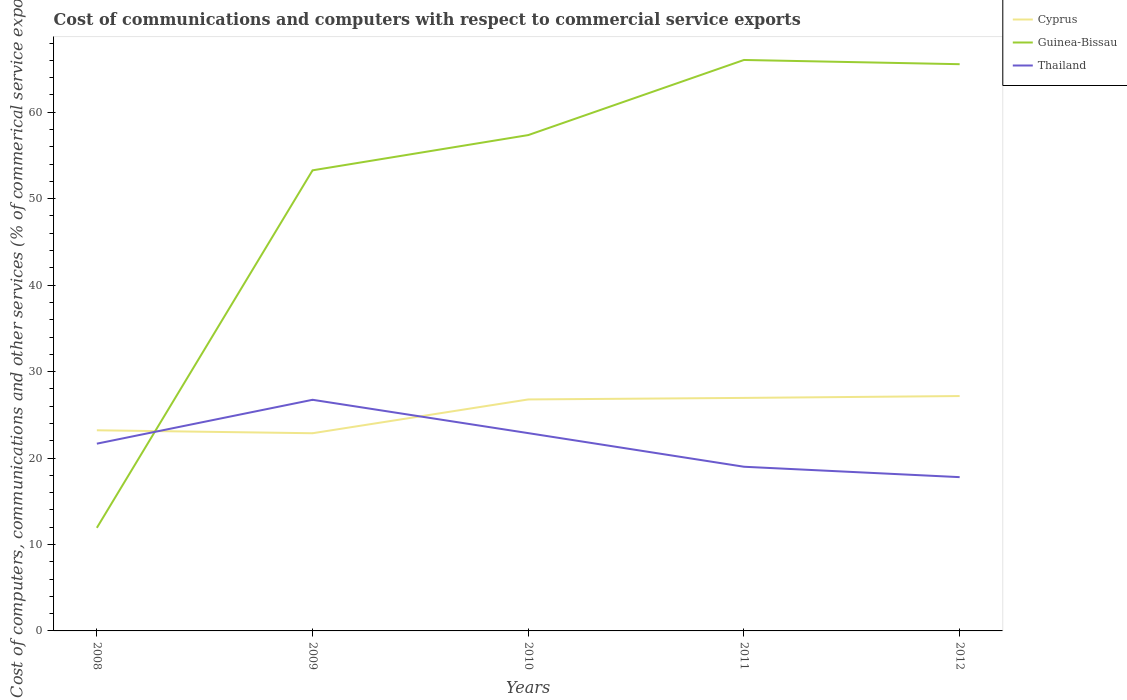Does the line corresponding to Guinea-Bissau intersect with the line corresponding to Cyprus?
Your response must be concise. Yes. Is the number of lines equal to the number of legend labels?
Offer a terse response. Yes. Across all years, what is the maximum cost of communications and computers in Guinea-Bissau?
Provide a short and direct response. 11.93. What is the total cost of communications and computers in Thailand in the graph?
Your response must be concise. 7.75. What is the difference between the highest and the second highest cost of communications and computers in Guinea-Bissau?
Keep it short and to the point. 54.12. How many years are there in the graph?
Make the answer very short. 5. Does the graph contain any zero values?
Offer a very short reply. No. Where does the legend appear in the graph?
Keep it short and to the point. Top right. How many legend labels are there?
Your answer should be compact. 3. How are the legend labels stacked?
Provide a short and direct response. Vertical. What is the title of the graph?
Make the answer very short. Cost of communications and computers with respect to commercial service exports. Does "Barbados" appear as one of the legend labels in the graph?
Provide a succinct answer. No. What is the label or title of the Y-axis?
Give a very brief answer. Cost of computers, communications and other services (% of commerical service exports). What is the Cost of computers, communications and other services (% of commerical service exports) of Cyprus in 2008?
Give a very brief answer. 23.21. What is the Cost of computers, communications and other services (% of commerical service exports) of Guinea-Bissau in 2008?
Your answer should be compact. 11.93. What is the Cost of computers, communications and other services (% of commerical service exports) in Thailand in 2008?
Make the answer very short. 21.66. What is the Cost of computers, communications and other services (% of commerical service exports) of Cyprus in 2009?
Your answer should be compact. 22.87. What is the Cost of computers, communications and other services (% of commerical service exports) in Guinea-Bissau in 2009?
Your answer should be compact. 53.28. What is the Cost of computers, communications and other services (% of commerical service exports) of Thailand in 2009?
Ensure brevity in your answer.  26.74. What is the Cost of computers, communications and other services (% of commerical service exports) of Cyprus in 2010?
Give a very brief answer. 26.78. What is the Cost of computers, communications and other services (% of commerical service exports) in Guinea-Bissau in 2010?
Your answer should be compact. 57.36. What is the Cost of computers, communications and other services (% of commerical service exports) of Thailand in 2010?
Keep it short and to the point. 22.88. What is the Cost of computers, communications and other services (% of commerical service exports) in Cyprus in 2011?
Keep it short and to the point. 26.95. What is the Cost of computers, communications and other services (% of commerical service exports) in Guinea-Bissau in 2011?
Provide a short and direct response. 66.05. What is the Cost of computers, communications and other services (% of commerical service exports) in Thailand in 2011?
Provide a short and direct response. 18.99. What is the Cost of computers, communications and other services (% of commerical service exports) of Cyprus in 2012?
Give a very brief answer. 27.17. What is the Cost of computers, communications and other services (% of commerical service exports) in Guinea-Bissau in 2012?
Offer a very short reply. 65.56. What is the Cost of computers, communications and other services (% of commerical service exports) in Thailand in 2012?
Make the answer very short. 17.79. Across all years, what is the maximum Cost of computers, communications and other services (% of commerical service exports) in Cyprus?
Provide a short and direct response. 27.17. Across all years, what is the maximum Cost of computers, communications and other services (% of commerical service exports) in Guinea-Bissau?
Your answer should be compact. 66.05. Across all years, what is the maximum Cost of computers, communications and other services (% of commerical service exports) in Thailand?
Make the answer very short. 26.74. Across all years, what is the minimum Cost of computers, communications and other services (% of commerical service exports) of Cyprus?
Provide a short and direct response. 22.87. Across all years, what is the minimum Cost of computers, communications and other services (% of commerical service exports) in Guinea-Bissau?
Offer a very short reply. 11.93. Across all years, what is the minimum Cost of computers, communications and other services (% of commerical service exports) in Thailand?
Your response must be concise. 17.79. What is the total Cost of computers, communications and other services (% of commerical service exports) of Cyprus in the graph?
Ensure brevity in your answer.  126.98. What is the total Cost of computers, communications and other services (% of commerical service exports) of Guinea-Bissau in the graph?
Keep it short and to the point. 254.17. What is the total Cost of computers, communications and other services (% of commerical service exports) in Thailand in the graph?
Your response must be concise. 108.06. What is the difference between the Cost of computers, communications and other services (% of commerical service exports) of Cyprus in 2008 and that in 2009?
Keep it short and to the point. 0.34. What is the difference between the Cost of computers, communications and other services (% of commerical service exports) of Guinea-Bissau in 2008 and that in 2009?
Your response must be concise. -41.35. What is the difference between the Cost of computers, communications and other services (% of commerical service exports) of Thailand in 2008 and that in 2009?
Provide a short and direct response. -5.08. What is the difference between the Cost of computers, communications and other services (% of commerical service exports) of Cyprus in 2008 and that in 2010?
Your answer should be compact. -3.57. What is the difference between the Cost of computers, communications and other services (% of commerical service exports) of Guinea-Bissau in 2008 and that in 2010?
Provide a succinct answer. -45.43. What is the difference between the Cost of computers, communications and other services (% of commerical service exports) in Thailand in 2008 and that in 2010?
Keep it short and to the point. -1.22. What is the difference between the Cost of computers, communications and other services (% of commerical service exports) of Cyprus in 2008 and that in 2011?
Provide a short and direct response. -3.74. What is the difference between the Cost of computers, communications and other services (% of commerical service exports) of Guinea-Bissau in 2008 and that in 2011?
Keep it short and to the point. -54.12. What is the difference between the Cost of computers, communications and other services (% of commerical service exports) in Thailand in 2008 and that in 2011?
Provide a succinct answer. 2.67. What is the difference between the Cost of computers, communications and other services (% of commerical service exports) in Cyprus in 2008 and that in 2012?
Offer a terse response. -3.96. What is the difference between the Cost of computers, communications and other services (% of commerical service exports) in Guinea-Bissau in 2008 and that in 2012?
Ensure brevity in your answer.  -53.63. What is the difference between the Cost of computers, communications and other services (% of commerical service exports) of Thailand in 2008 and that in 2012?
Offer a terse response. 3.87. What is the difference between the Cost of computers, communications and other services (% of commerical service exports) of Cyprus in 2009 and that in 2010?
Offer a very short reply. -3.91. What is the difference between the Cost of computers, communications and other services (% of commerical service exports) in Guinea-Bissau in 2009 and that in 2010?
Keep it short and to the point. -4.08. What is the difference between the Cost of computers, communications and other services (% of commerical service exports) in Thailand in 2009 and that in 2010?
Your answer should be compact. 3.86. What is the difference between the Cost of computers, communications and other services (% of commerical service exports) in Cyprus in 2009 and that in 2011?
Provide a short and direct response. -4.09. What is the difference between the Cost of computers, communications and other services (% of commerical service exports) of Guinea-Bissau in 2009 and that in 2011?
Your answer should be very brief. -12.77. What is the difference between the Cost of computers, communications and other services (% of commerical service exports) of Thailand in 2009 and that in 2011?
Make the answer very short. 7.75. What is the difference between the Cost of computers, communications and other services (% of commerical service exports) of Cyprus in 2009 and that in 2012?
Keep it short and to the point. -4.3. What is the difference between the Cost of computers, communications and other services (% of commerical service exports) of Guinea-Bissau in 2009 and that in 2012?
Offer a terse response. -12.28. What is the difference between the Cost of computers, communications and other services (% of commerical service exports) in Thailand in 2009 and that in 2012?
Offer a terse response. 8.95. What is the difference between the Cost of computers, communications and other services (% of commerical service exports) of Cyprus in 2010 and that in 2011?
Provide a short and direct response. -0.18. What is the difference between the Cost of computers, communications and other services (% of commerical service exports) of Guinea-Bissau in 2010 and that in 2011?
Offer a very short reply. -8.69. What is the difference between the Cost of computers, communications and other services (% of commerical service exports) of Thailand in 2010 and that in 2011?
Keep it short and to the point. 3.89. What is the difference between the Cost of computers, communications and other services (% of commerical service exports) in Cyprus in 2010 and that in 2012?
Your answer should be very brief. -0.39. What is the difference between the Cost of computers, communications and other services (% of commerical service exports) of Guinea-Bissau in 2010 and that in 2012?
Offer a terse response. -8.2. What is the difference between the Cost of computers, communications and other services (% of commerical service exports) of Thailand in 2010 and that in 2012?
Your answer should be very brief. 5.09. What is the difference between the Cost of computers, communications and other services (% of commerical service exports) of Cyprus in 2011 and that in 2012?
Offer a very short reply. -0.22. What is the difference between the Cost of computers, communications and other services (% of commerical service exports) of Guinea-Bissau in 2011 and that in 2012?
Provide a short and direct response. 0.49. What is the difference between the Cost of computers, communications and other services (% of commerical service exports) of Thailand in 2011 and that in 2012?
Provide a succinct answer. 1.2. What is the difference between the Cost of computers, communications and other services (% of commerical service exports) of Cyprus in 2008 and the Cost of computers, communications and other services (% of commerical service exports) of Guinea-Bissau in 2009?
Offer a very short reply. -30.07. What is the difference between the Cost of computers, communications and other services (% of commerical service exports) of Cyprus in 2008 and the Cost of computers, communications and other services (% of commerical service exports) of Thailand in 2009?
Offer a very short reply. -3.53. What is the difference between the Cost of computers, communications and other services (% of commerical service exports) in Guinea-Bissau in 2008 and the Cost of computers, communications and other services (% of commerical service exports) in Thailand in 2009?
Your answer should be very brief. -14.81. What is the difference between the Cost of computers, communications and other services (% of commerical service exports) of Cyprus in 2008 and the Cost of computers, communications and other services (% of commerical service exports) of Guinea-Bissau in 2010?
Give a very brief answer. -34.15. What is the difference between the Cost of computers, communications and other services (% of commerical service exports) of Cyprus in 2008 and the Cost of computers, communications and other services (% of commerical service exports) of Thailand in 2010?
Your response must be concise. 0.33. What is the difference between the Cost of computers, communications and other services (% of commerical service exports) in Guinea-Bissau in 2008 and the Cost of computers, communications and other services (% of commerical service exports) in Thailand in 2010?
Offer a terse response. -10.96. What is the difference between the Cost of computers, communications and other services (% of commerical service exports) of Cyprus in 2008 and the Cost of computers, communications and other services (% of commerical service exports) of Guinea-Bissau in 2011?
Ensure brevity in your answer.  -42.84. What is the difference between the Cost of computers, communications and other services (% of commerical service exports) of Cyprus in 2008 and the Cost of computers, communications and other services (% of commerical service exports) of Thailand in 2011?
Provide a short and direct response. 4.22. What is the difference between the Cost of computers, communications and other services (% of commerical service exports) in Guinea-Bissau in 2008 and the Cost of computers, communications and other services (% of commerical service exports) in Thailand in 2011?
Keep it short and to the point. -7.07. What is the difference between the Cost of computers, communications and other services (% of commerical service exports) in Cyprus in 2008 and the Cost of computers, communications and other services (% of commerical service exports) in Guinea-Bissau in 2012?
Provide a short and direct response. -42.35. What is the difference between the Cost of computers, communications and other services (% of commerical service exports) in Cyprus in 2008 and the Cost of computers, communications and other services (% of commerical service exports) in Thailand in 2012?
Make the answer very short. 5.42. What is the difference between the Cost of computers, communications and other services (% of commerical service exports) in Guinea-Bissau in 2008 and the Cost of computers, communications and other services (% of commerical service exports) in Thailand in 2012?
Your response must be concise. -5.86. What is the difference between the Cost of computers, communications and other services (% of commerical service exports) in Cyprus in 2009 and the Cost of computers, communications and other services (% of commerical service exports) in Guinea-Bissau in 2010?
Keep it short and to the point. -34.49. What is the difference between the Cost of computers, communications and other services (% of commerical service exports) of Cyprus in 2009 and the Cost of computers, communications and other services (% of commerical service exports) of Thailand in 2010?
Provide a succinct answer. -0.01. What is the difference between the Cost of computers, communications and other services (% of commerical service exports) of Guinea-Bissau in 2009 and the Cost of computers, communications and other services (% of commerical service exports) of Thailand in 2010?
Keep it short and to the point. 30.4. What is the difference between the Cost of computers, communications and other services (% of commerical service exports) in Cyprus in 2009 and the Cost of computers, communications and other services (% of commerical service exports) in Guinea-Bissau in 2011?
Offer a very short reply. -43.18. What is the difference between the Cost of computers, communications and other services (% of commerical service exports) of Cyprus in 2009 and the Cost of computers, communications and other services (% of commerical service exports) of Thailand in 2011?
Your response must be concise. 3.88. What is the difference between the Cost of computers, communications and other services (% of commerical service exports) of Guinea-Bissau in 2009 and the Cost of computers, communications and other services (% of commerical service exports) of Thailand in 2011?
Provide a short and direct response. 34.29. What is the difference between the Cost of computers, communications and other services (% of commerical service exports) of Cyprus in 2009 and the Cost of computers, communications and other services (% of commerical service exports) of Guinea-Bissau in 2012?
Keep it short and to the point. -42.69. What is the difference between the Cost of computers, communications and other services (% of commerical service exports) of Cyprus in 2009 and the Cost of computers, communications and other services (% of commerical service exports) of Thailand in 2012?
Offer a very short reply. 5.08. What is the difference between the Cost of computers, communications and other services (% of commerical service exports) of Guinea-Bissau in 2009 and the Cost of computers, communications and other services (% of commerical service exports) of Thailand in 2012?
Provide a short and direct response. 35.49. What is the difference between the Cost of computers, communications and other services (% of commerical service exports) in Cyprus in 2010 and the Cost of computers, communications and other services (% of commerical service exports) in Guinea-Bissau in 2011?
Ensure brevity in your answer.  -39.27. What is the difference between the Cost of computers, communications and other services (% of commerical service exports) in Cyprus in 2010 and the Cost of computers, communications and other services (% of commerical service exports) in Thailand in 2011?
Ensure brevity in your answer.  7.79. What is the difference between the Cost of computers, communications and other services (% of commerical service exports) in Guinea-Bissau in 2010 and the Cost of computers, communications and other services (% of commerical service exports) in Thailand in 2011?
Offer a very short reply. 38.37. What is the difference between the Cost of computers, communications and other services (% of commerical service exports) of Cyprus in 2010 and the Cost of computers, communications and other services (% of commerical service exports) of Guinea-Bissau in 2012?
Offer a terse response. -38.78. What is the difference between the Cost of computers, communications and other services (% of commerical service exports) of Cyprus in 2010 and the Cost of computers, communications and other services (% of commerical service exports) of Thailand in 2012?
Your answer should be very brief. 8.99. What is the difference between the Cost of computers, communications and other services (% of commerical service exports) in Guinea-Bissau in 2010 and the Cost of computers, communications and other services (% of commerical service exports) in Thailand in 2012?
Offer a terse response. 39.57. What is the difference between the Cost of computers, communications and other services (% of commerical service exports) of Cyprus in 2011 and the Cost of computers, communications and other services (% of commerical service exports) of Guinea-Bissau in 2012?
Make the answer very short. -38.6. What is the difference between the Cost of computers, communications and other services (% of commerical service exports) in Cyprus in 2011 and the Cost of computers, communications and other services (% of commerical service exports) in Thailand in 2012?
Give a very brief answer. 9.16. What is the difference between the Cost of computers, communications and other services (% of commerical service exports) of Guinea-Bissau in 2011 and the Cost of computers, communications and other services (% of commerical service exports) of Thailand in 2012?
Provide a succinct answer. 48.26. What is the average Cost of computers, communications and other services (% of commerical service exports) in Cyprus per year?
Offer a very short reply. 25.4. What is the average Cost of computers, communications and other services (% of commerical service exports) in Guinea-Bissau per year?
Keep it short and to the point. 50.83. What is the average Cost of computers, communications and other services (% of commerical service exports) in Thailand per year?
Provide a short and direct response. 21.61. In the year 2008, what is the difference between the Cost of computers, communications and other services (% of commerical service exports) in Cyprus and Cost of computers, communications and other services (% of commerical service exports) in Guinea-Bissau?
Offer a very short reply. 11.28. In the year 2008, what is the difference between the Cost of computers, communications and other services (% of commerical service exports) of Cyprus and Cost of computers, communications and other services (% of commerical service exports) of Thailand?
Your answer should be very brief. 1.55. In the year 2008, what is the difference between the Cost of computers, communications and other services (% of commerical service exports) in Guinea-Bissau and Cost of computers, communications and other services (% of commerical service exports) in Thailand?
Provide a short and direct response. -9.74. In the year 2009, what is the difference between the Cost of computers, communications and other services (% of commerical service exports) in Cyprus and Cost of computers, communications and other services (% of commerical service exports) in Guinea-Bissau?
Provide a short and direct response. -30.41. In the year 2009, what is the difference between the Cost of computers, communications and other services (% of commerical service exports) of Cyprus and Cost of computers, communications and other services (% of commerical service exports) of Thailand?
Provide a short and direct response. -3.87. In the year 2009, what is the difference between the Cost of computers, communications and other services (% of commerical service exports) in Guinea-Bissau and Cost of computers, communications and other services (% of commerical service exports) in Thailand?
Your answer should be very brief. 26.54. In the year 2010, what is the difference between the Cost of computers, communications and other services (% of commerical service exports) in Cyprus and Cost of computers, communications and other services (% of commerical service exports) in Guinea-Bissau?
Make the answer very short. -30.58. In the year 2010, what is the difference between the Cost of computers, communications and other services (% of commerical service exports) in Cyprus and Cost of computers, communications and other services (% of commerical service exports) in Thailand?
Make the answer very short. 3.9. In the year 2010, what is the difference between the Cost of computers, communications and other services (% of commerical service exports) in Guinea-Bissau and Cost of computers, communications and other services (% of commerical service exports) in Thailand?
Your answer should be compact. 34.48. In the year 2011, what is the difference between the Cost of computers, communications and other services (% of commerical service exports) of Cyprus and Cost of computers, communications and other services (% of commerical service exports) of Guinea-Bissau?
Make the answer very short. -39.09. In the year 2011, what is the difference between the Cost of computers, communications and other services (% of commerical service exports) of Cyprus and Cost of computers, communications and other services (% of commerical service exports) of Thailand?
Offer a very short reply. 7.96. In the year 2011, what is the difference between the Cost of computers, communications and other services (% of commerical service exports) of Guinea-Bissau and Cost of computers, communications and other services (% of commerical service exports) of Thailand?
Make the answer very short. 47.06. In the year 2012, what is the difference between the Cost of computers, communications and other services (% of commerical service exports) of Cyprus and Cost of computers, communications and other services (% of commerical service exports) of Guinea-Bissau?
Provide a short and direct response. -38.39. In the year 2012, what is the difference between the Cost of computers, communications and other services (% of commerical service exports) of Cyprus and Cost of computers, communications and other services (% of commerical service exports) of Thailand?
Provide a short and direct response. 9.38. In the year 2012, what is the difference between the Cost of computers, communications and other services (% of commerical service exports) in Guinea-Bissau and Cost of computers, communications and other services (% of commerical service exports) in Thailand?
Ensure brevity in your answer.  47.77. What is the ratio of the Cost of computers, communications and other services (% of commerical service exports) in Cyprus in 2008 to that in 2009?
Make the answer very short. 1.01. What is the ratio of the Cost of computers, communications and other services (% of commerical service exports) in Guinea-Bissau in 2008 to that in 2009?
Provide a succinct answer. 0.22. What is the ratio of the Cost of computers, communications and other services (% of commerical service exports) of Thailand in 2008 to that in 2009?
Your response must be concise. 0.81. What is the ratio of the Cost of computers, communications and other services (% of commerical service exports) of Cyprus in 2008 to that in 2010?
Your answer should be very brief. 0.87. What is the ratio of the Cost of computers, communications and other services (% of commerical service exports) of Guinea-Bissau in 2008 to that in 2010?
Ensure brevity in your answer.  0.21. What is the ratio of the Cost of computers, communications and other services (% of commerical service exports) of Thailand in 2008 to that in 2010?
Give a very brief answer. 0.95. What is the ratio of the Cost of computers, communications and other services (% of commerical service exports) in Cyprus in 2008 to that in 2011?
Your answer should be compact. 0.86. What is the ratio of the Cost of computers, communications and other services (% of commerical service exports) of Guinea-Bissau in 2008 to that in 2011?
Offer a very short reply. 0.18. What is the ratio of the Cost of computers, communications and other services (% of commerical service exports) of Thailand in 2008 to that in 2011?
Your response must be concise. 1.14. What is the ratio of the Cost of computers, communications and other services (% of commerical service exports) of Cyprus in 2008 to that in 2012?
Make the answer very short. 0.85. What is the ratio of the Cost of computers, communications and other services (% of commerical service exports) in Guinea-Bissau in 2008 to that in 2012?
Provide a short and direct response. 0.18. What is the ratio of the Cost of computers, communications and other services (% of commerical service exports) of Thailand in 2008 to that in 2012?
Offer a very short reply. 1.22. What is the ratio of the Cost of computers, communications and other services (% of commerical service exports) of Cyprus in 2009 to that in 2010?
Keep it short and to the point. 0.85. What is the ratio of the Cost of computers, communications and other services (% of commerical service exports) in Guinea-Bissau in 2009 to that in 2010?
Your answer should be very brief. 0.93. What is the ratio of the Cost of computers, communications and other services (% of commerical service exports) in Thailand in 2009 to that in 2010?
Make the answer very short. 1.17. What is the ratio of the Cost of computers, communications and other services (% of commerical service exports) of Cyprus in 2009 to that in 2011?
Offer a very short reply. 0.85. What is the ratio of the Cost of computers, communications and other services (% of commerical service exports) of Guinea-Bissau in 2009 to that in 2011?
Keep it short and to the point. 0.81. What is the ratio of the Cost of computers, communications and other services (% of commerical service exports) of Thailand in 2009 to that in 2011?
Your answer should be very brief. 1.41. What is the ratio of the Cost of computers, communications and other services (% of commerical service exports) in Cyprus in 2009 to that in 2012?
Keep it short and to the point. 0.84. What is the ratio of the Cost of computers, communications and other services (% of commerical service exports) of Guinea-Bissau in 2009 to that in 2012?
Your answer should be compact. 0.81. What is the ratio of the Cost of computers, communications and other services (% of commerical service exports) of Thailand in 2009 to that in 2012?
Ensure brevity in your answer.  1.5. What is the ratio of the Cost of computers, communications and other services (% of commerical service exports) of Cyprus in 2010 to that in 2011?
Make the answer very short. 0.99. What is the ratio of the Cost of computers, communications and other services (% of commerical service exports) of Guinea-Bissau in 2010 to that in 2011?
Keep it short and to the point. 0.87. What is the ratio of the Cost of computers, communications and other services (% of commerical service exports) in Thailand in 2010 to that in 2011?
Provide a succinct answer. 1.2. What is the ratio of the Cost of computers, communications and other services (% of commerical service exports) in Cyprus in 2010 to that in 2012?
Provide a short and direct response. 0.99. What is the ratio of the Cost of computers, communications and other services (% of commerical service exports) of Guinea-Bissau in 2010 to that in 2012?
Make the answer very short. 0.87. What is the ratio of the Cost of computers, communications and other services (% of commerical service exports) in Thailand in 2010 to that in 2012?
Provide a succinct answer. 1.29. What is the ratio of the Cost of computers, communications and other services (% of commerical service exports) of Guinea-Bissau in 2011 to that in 2012?
Your answer should be compact. 1.01. What is the ratio of the Cost of computers, communications and other services (% of commerical service exports) in Thailand in 2011 to that in 2012?
Ensure brevity in your answer.  1.07. What is the difference between the highest and the second highest Cost of computers, communications and other services (% of commerical service exports) in Cyprus?
Give a very brief answer. 0.22. What is the difference between the highest and the second highest Cost of computers, communications and other services (% of commerical service exports) in Guinea-Bissau?
Provide a succinct answer. 0.49. What is the difference between the highest and the second highest Cost of computers, communications and other services (% of commerical service exports) of Thailand?
Ensure brevity in your answer.  3.86. What is the difference between the highest and the lowest Cost of computers, communications and other services (% of commerical service exports) of Cyprus?
Provide a short and direct response. 4.3. What is the difference between the highest and the lowest Cost of computers, communications and other services (% of commerical service exports) of Guinea-Bissau?
Ensure brevity in your answer.  54.12. What is the difference between the highest and the lowest Cost of computers, communications and other services (% of commerical service exports) in Thailand?
Make the answer very short. 8.95. 